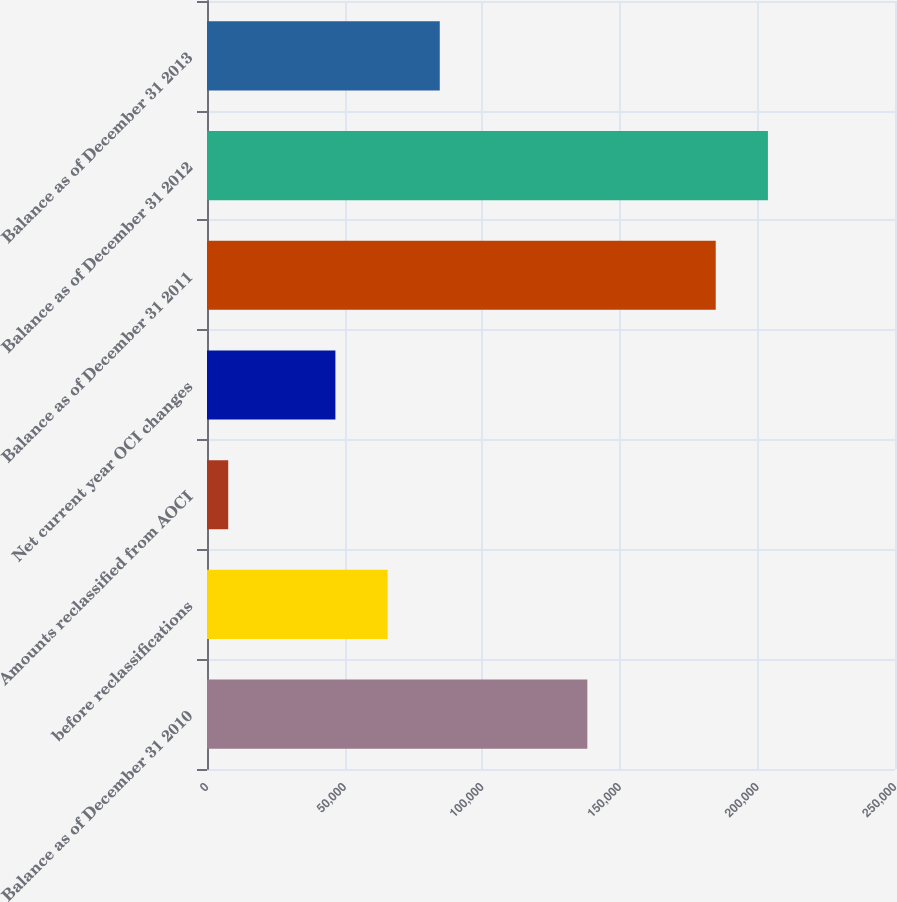<chart> <loc_0><loc_0><loc_500><loc_500><bar_chart><fcel>Balance as of December 31 2010<fcel>before reclassifications<fcel>Amounts reclassified from AOCI<fcel>Net current year OCI changes<fcel>Balance as of December 31 2011<fcel>Balance as of December 31 2012<fcel>Balance as of December 31 2013<nl><fcel>138202<fcel>65619.7<fcel>7710<fcel>46656<fcel>184858<fcel>203822<fcel>84583.4<nl></chart> 